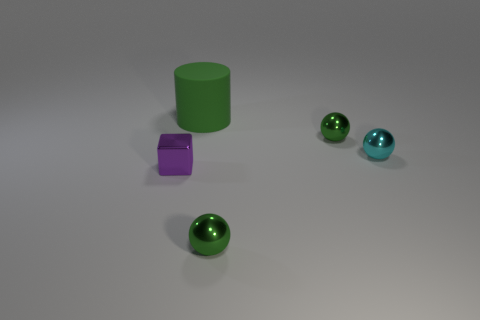Add 4 big green cylinders. How many objects exist? 9 Subtract all green balls. How many balls are left? 1 Subtract all green spheres. How many spheres are left? 1 Subtract 2 balls. How many balls are left? 1 Subtract all brown cylinders. Subtract all green blocks. How many cylinders are left? 1 Subtract all green balls. How many red cylinders are left? 0 Subtract all cyan things. Subtract all large gray shiny cylinders. How many objects are left? 4 Add 1 green matte cylinders. How many green matte cylinders are left? 2 Add 3 small cyan things. How many small cyan things exist? 4 Subtract 1 green spheres. How many objects are left? 4 